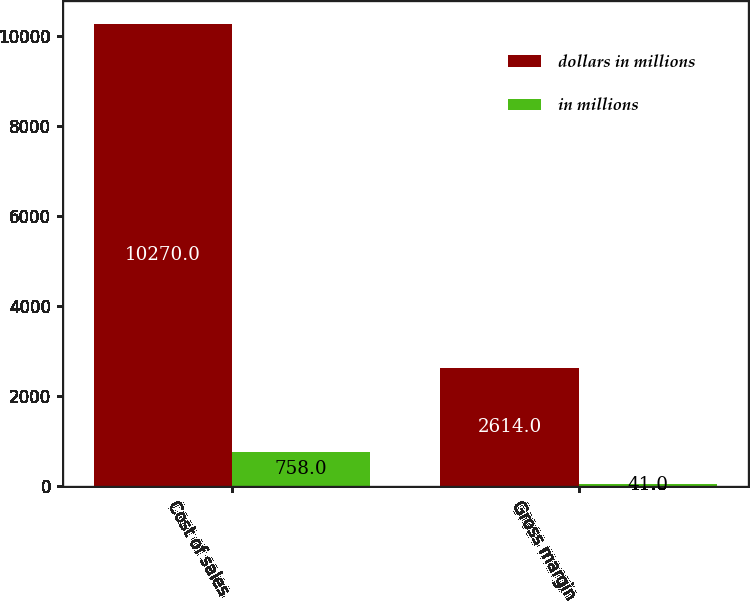Convert chart. <chart><loc_0><loc_0><loc_500><loc_500><stacked_bar_chart><ecel><fcel>Cost of sales<fcel>Gross margin<nl><fcel>dollars in millions<fcel>10270<fcel>2614<nl><fcel>in millions<fcel>758<fcel>41<nl></chart> 